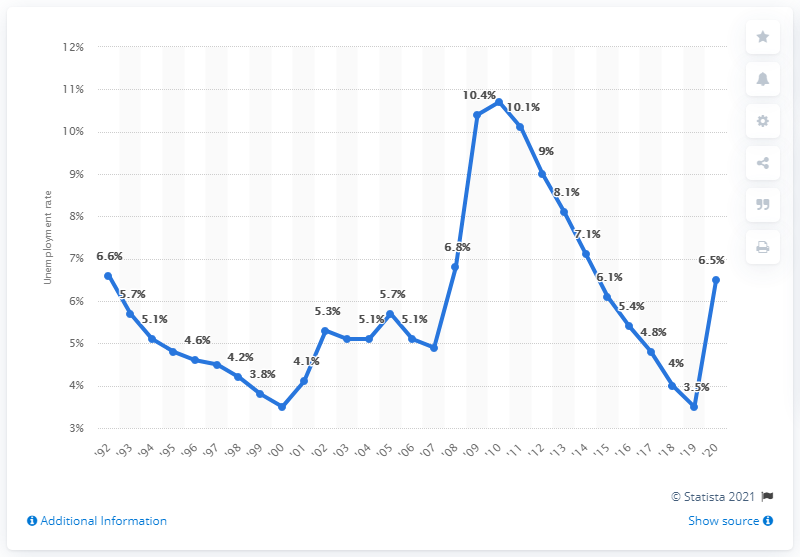Indicate a few pertinent items in this graphic. In 2020, the unemployment rate in Georgia was 6.5%. 